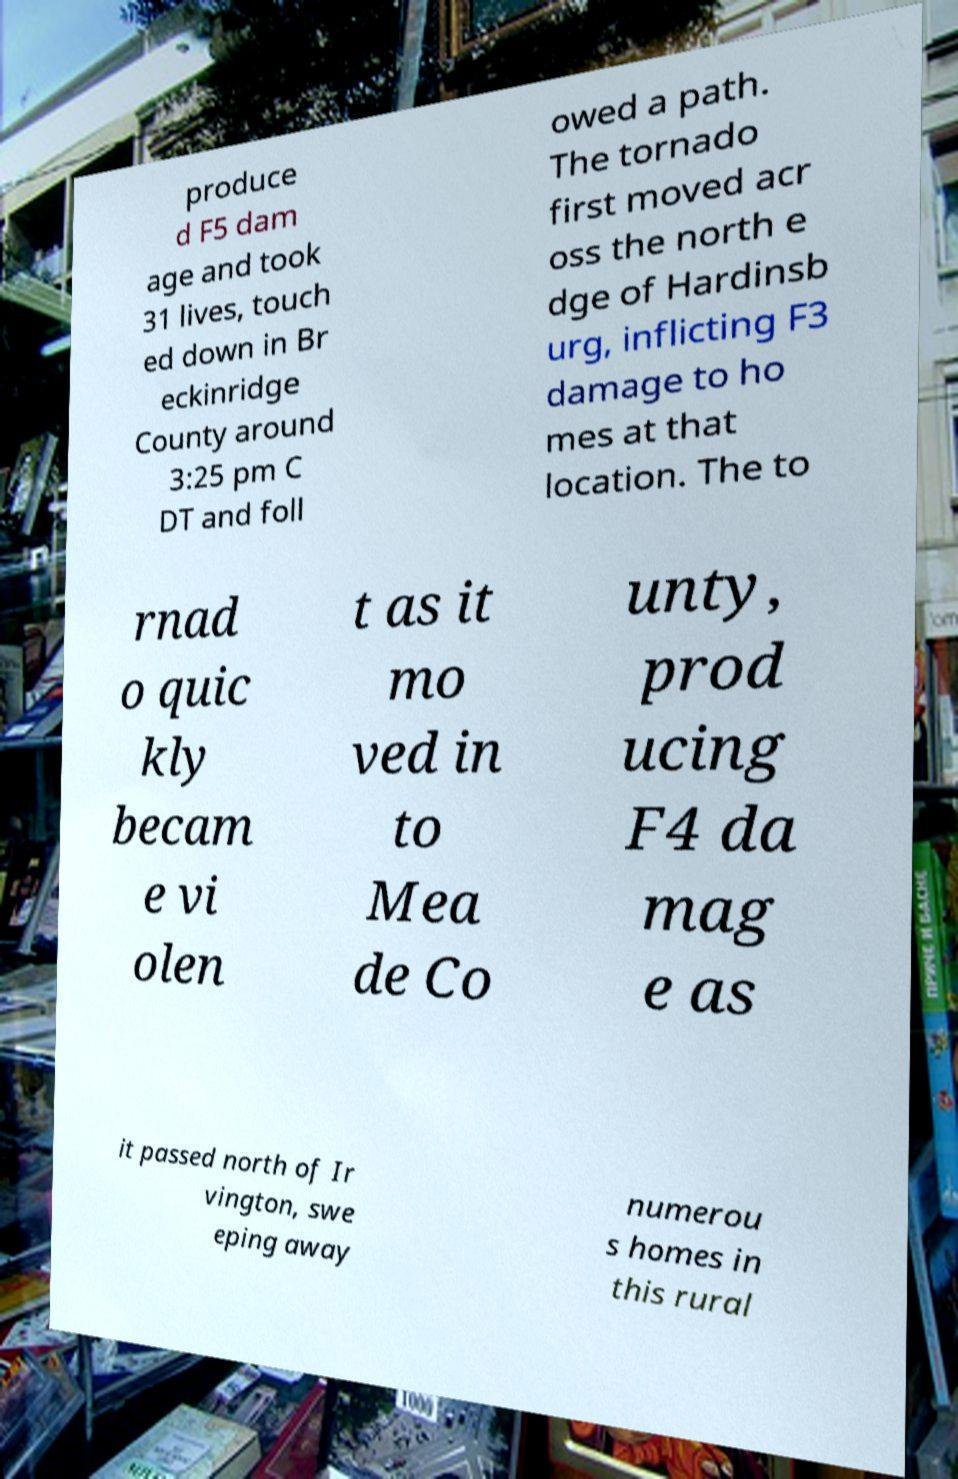Can you accurately transcribe the text from the provided image for me? produce d F5 dam age and took 31 lives, touch ed down in Br eckinridge County around 3:25 pm C DT and foll owed a path. The tornado first moved acr oss the north e dge of Hardinsb urg, inflicting F3 damage to ho mes at that location. The to rnad o quic kly becam e vi olen t as it mo ved in to Mea de Co unty, prod ucing F4 da mag e as it passed north of Ir vington, swe eping away numerou s homes in this rural 